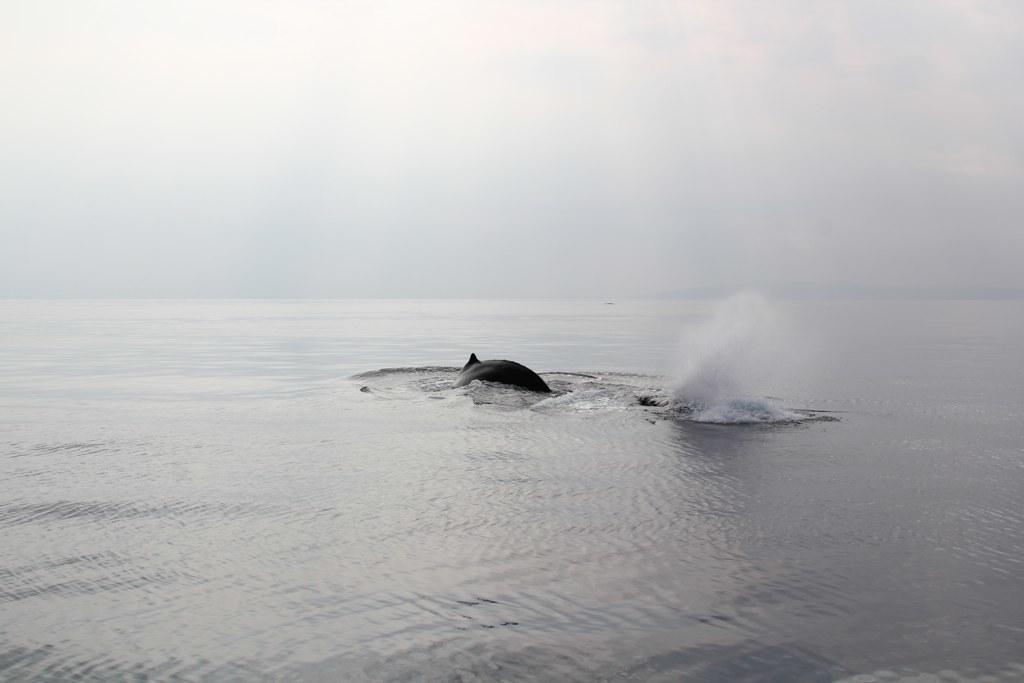What is happening in the sea in the image? There are fishes swimming in the sea in the image. What is the condition of the sky in the image? The sky is clear in the image. Where is the veil located in the image? There is no veil present in the image. What type of loss is depicted in the image? There is no loss depicted in the image; it features fishes swimming in the sea and a clear sky. 